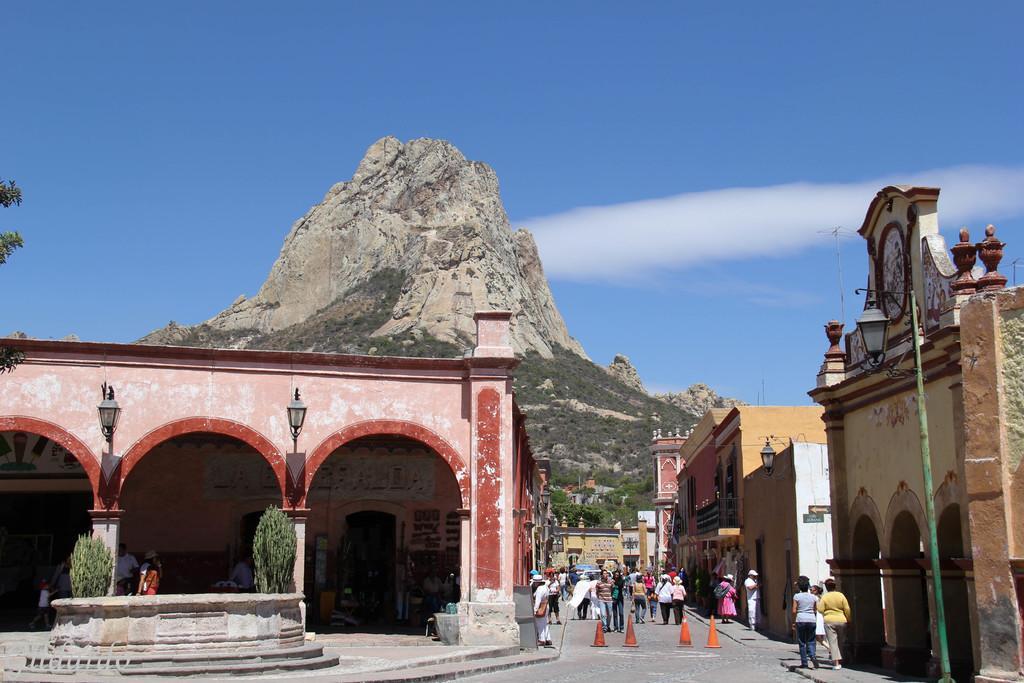In one or two sentences, can you explain what this image depicts? In this image I can see a road in the centre and on it I can see few orange colour cones and number of people are standing. On the both side of the road I can see number of buildings and few lights. On the left side of this image I can see few more people, few plants and a tree. On the right side of this image I can see few poles. In the background I can see mountains, clouds and the sky. 